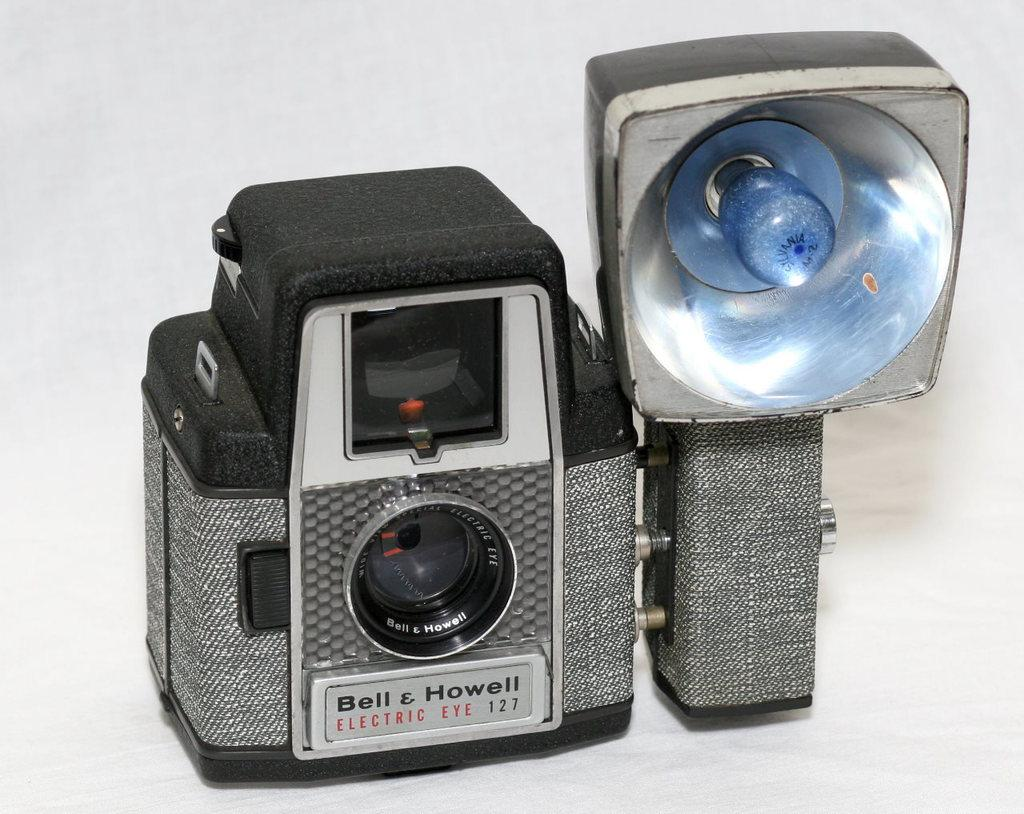<image>
Offer a succinct explanation of the picture presented. a camera with the name Bell on it 